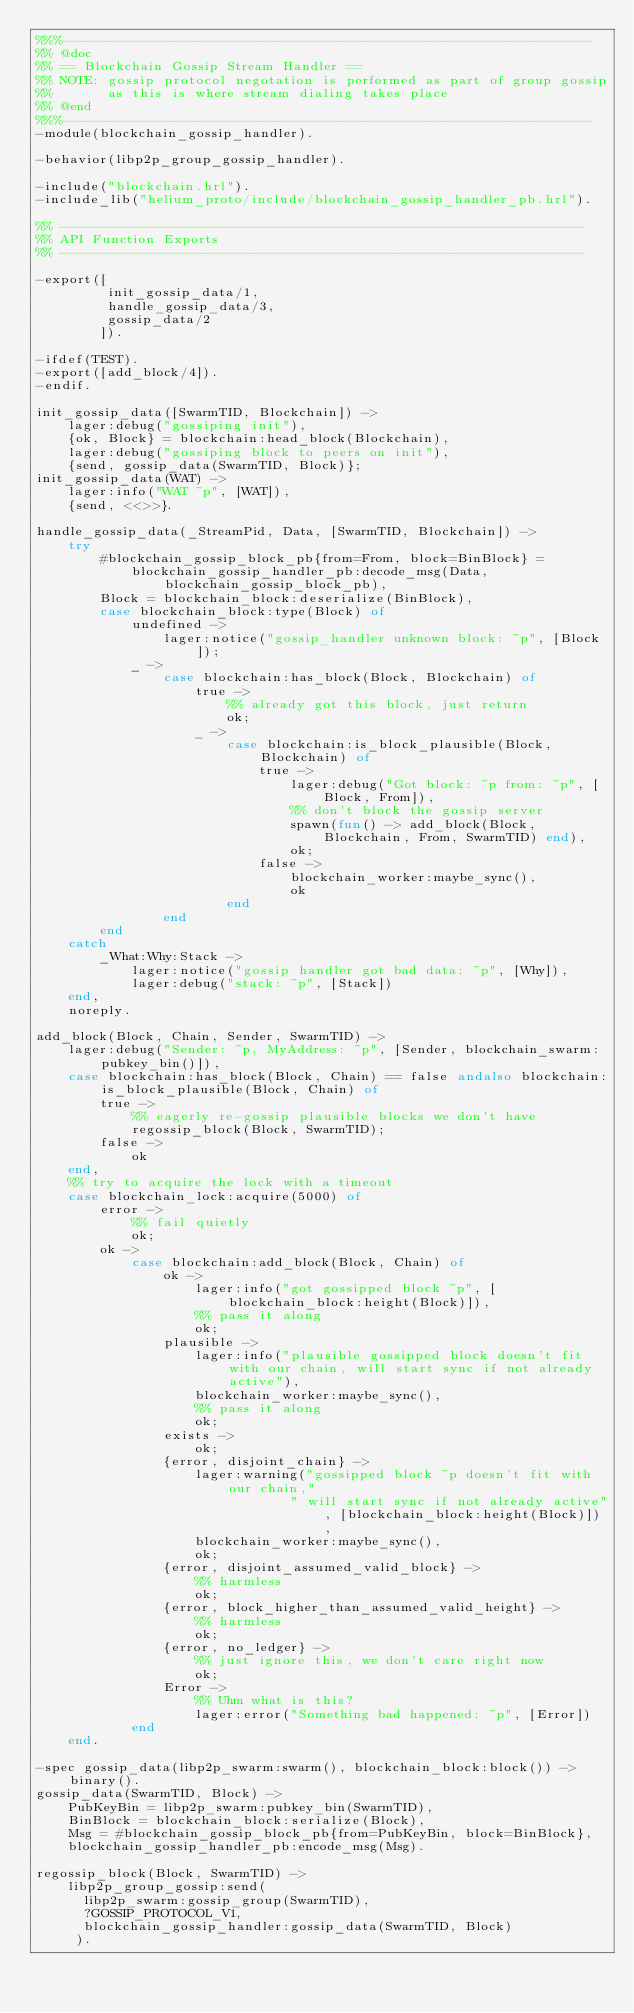<code> <loc_0><loc_0><loc_500><loc_500><_Erlang_>%%%-------------------------------------------------------------------
%% @doc
%% == Blockchain Gossip Stream Handler ==
%% NOTE: gossip protocol negotation is performed as part of group gossip
%%       as this is where stream dialing takes place
%% @end
%%%-------------------------------------------------------------------
-module(blockchain_gossip_handler).

-behavior(libp2p_group_gossip_handler).

-include("blockchain.hrl").
-include_lib("helium_proto/include/blockchain_gossip_handler_pb.hrl").

%% ------------------------------------------------------------------
%% API Function Exports
%% ------------------------------------------------------------------

-export([
         init_gossip_data/1,
         handle_gossip_data/3,
         gossip_data/2
        ]).

-ifdef(TEST).
-export([add_block/4]).
-endif.

init_gossip_data([SwarmTID, Blockchain]) ->
    lager:debug("gossiping init"),
    {ok, Block} = blockchain:head_block(Blockchain),
    lager:debug("gossiping block to peers on init"),
    {send, gossip_data(SwarmTID, Block)};
init_gossip_data(WAT) ->
    lager:info("WAT ~p", [WAT]),
    {send, <<>>}.

handle_gossip_data(_StreamPid, Data, [SwarmTID, Blockchain]) ->
    try
        #blockchain_gossip_block_pb{from=From, block=BinBlock} =
            blockchain_gossip_handler_pb:decode_msg(Data, blockchain_gossip_block_pb),
        Block = blockchain_block:deserialize(BinBlock),
        case blockchain_block:type(Block) of
            undefined ->
                lager:notice("gossip_handler unknown block: ~p", [Block]);
            _ ->
                case blockchain:has_block(Block, Blockchain) of
                    true ->
                        %% already got this block, just return
                        ok;
                    _ ->
                        case blockchain:is_block_plausible(Block, Blockchain) of
                            true ->
                                lager:debug("Got block: ~p from: ~p", [Block, From]),
                                %% don't block the gossip server
                                spawn(fun() -> add_block(Block, Blockchain, From, SwarmTID) end),
                                ok;
                            false ->
                                blockchain_worker:maybe_sync(),
                                ok
                        end
                end
        end
    catch
        _What:Why:Stack ->
            lager:notice("gossip handler got bad data: ~p", [Why]),
            lager:debug("stack: ~p", [Stack])
    end,
    noreply.

add_block(Block, Chain, Sender, SwarmTID) ->
    lager:debug("Sender: ~p, MyAddress: ~p", [Sender, blockchain_swarm:pubkey_bin()]),
    case blockchain:has_block(Block, Chain) == false andalso blockchain:is_block_plausible(Block, Chain) of
        true ->
            %% eagerly re-gossip plausible blocks we don't have
            regossip_block(Block, SwarmTID);
        false ->
            ok
    end,
    %% try to acquire the lock with a timeout
    case blockchain_lock:acquire(5000) of
        error ->
            %% fail quietly
            ok;
        ok ->
            case blockchain:add_block(Block, Chain) of
                ok ->
                    lager:info("got gossipped block ~p", [blockchain_block:height(Block)]),
                    %% pass it along
                    ok;
                plausible ->
                    lager:info("plausible gossipped block doesn't fit with our chain, will start sync if not already active"),
                    blockchain_worker:maybe_sync(),
                    %% pass it along
                    ok;
                exists ->
                    ok;
                {error, disjoint_chain} ->
                    lager:warning("gossipped block ~p doesn't fit with our chain,"
                                " will start sync if not already active", [blockchain_block:height(Block)]),
                    blockchain_worker:maybe_sync(),
                    ok;
                {error, disjoint_assumed_valid_block} ->
                    %% harmless
                    ok;
                {error, block_higher_than_assumed_valid_height} ->
                    %% harmless
                    ok;
                {error, no_ledger} ->
                    %% just ignore this, we don't care right now
                    ok;
                Error ->
                    %% Uhm what is this?
                    lager:error("Something bad happened: ~p", [Error])
            end
    end.

-spec gossip_data(libp2p_swarm:swarm(), blockchain_block:block()) -> binary().
gossip_data(SwarmTID, Block) ->
    PubKeyBin = libp2p_swarm:pubkey_bin(SwarmTID),
    BinBlock = blockchain_block:serialize(Block),
    Msg = #blockchain_gossip_block_pb{from=PubKeyBin, block=BinBlock},
    blockchain_gossip_handler_pb:encode_msg(Msg).

regossip_block(Block, SwarmTID) ->
    libp2p_group_gossip:send(
      libp2p_swarm:gossip_group(SwarmTID),
      ?GOSSIP_PROTOCOL_V1,
      blockchain_gossip_handler:gossip_data(SwarmTID, Block)
     ).
</code> 